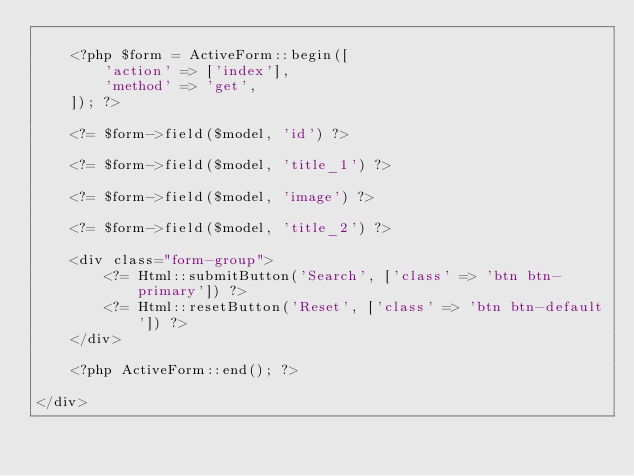Convert code to text. <code><loc_0><loc_0><loc_500><loc_500><_PHP_>
    <?php $form = ActiveForm::begin([
        'action' => ['index'],
        'method' => 'get',
    ]); ?>

    <?= $form->field($model, 'id') ?>

    <?= $form->field($model, 'title_1') ?>

    <?= $form->field($model, 'image') ?>

    <?= $form->field($model, 'title_2') ?>

    <div class="form-group">
        <?= Html::submitButton('Search', ['class' => 'btn btn-primary']) ?>
        <?= Html::resetButton('Reset', ['class' => 'btn btn-default']) ?>
    </div>

    <?php ActiveForm::end(); ?>

</div>
</code> 